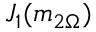<formula> <loc_0><loc_0><loc_500><loc_500>J _ { 1 } ( m _ { 2 \Omega } )</formula> 